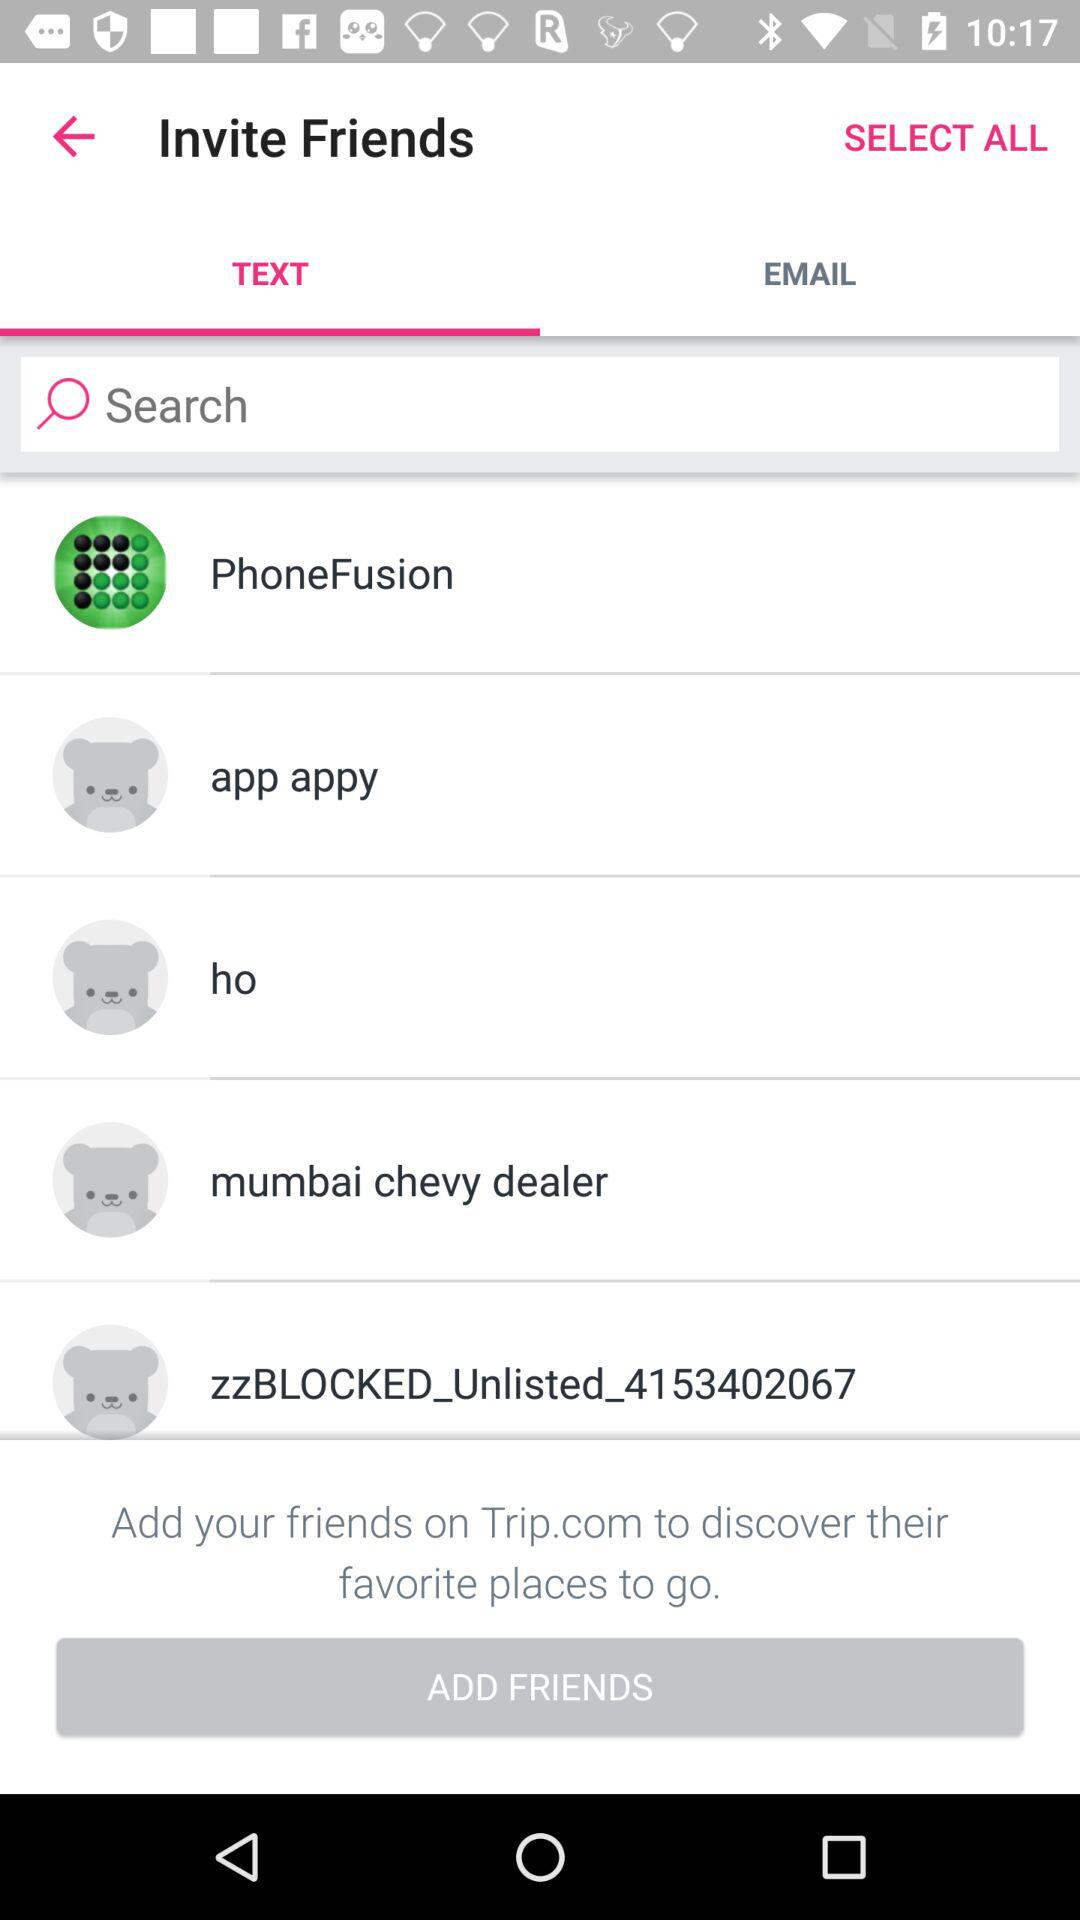How to discover friends favorite places to go? You can add your friends on Trip.com to discover their favorite places to go. 